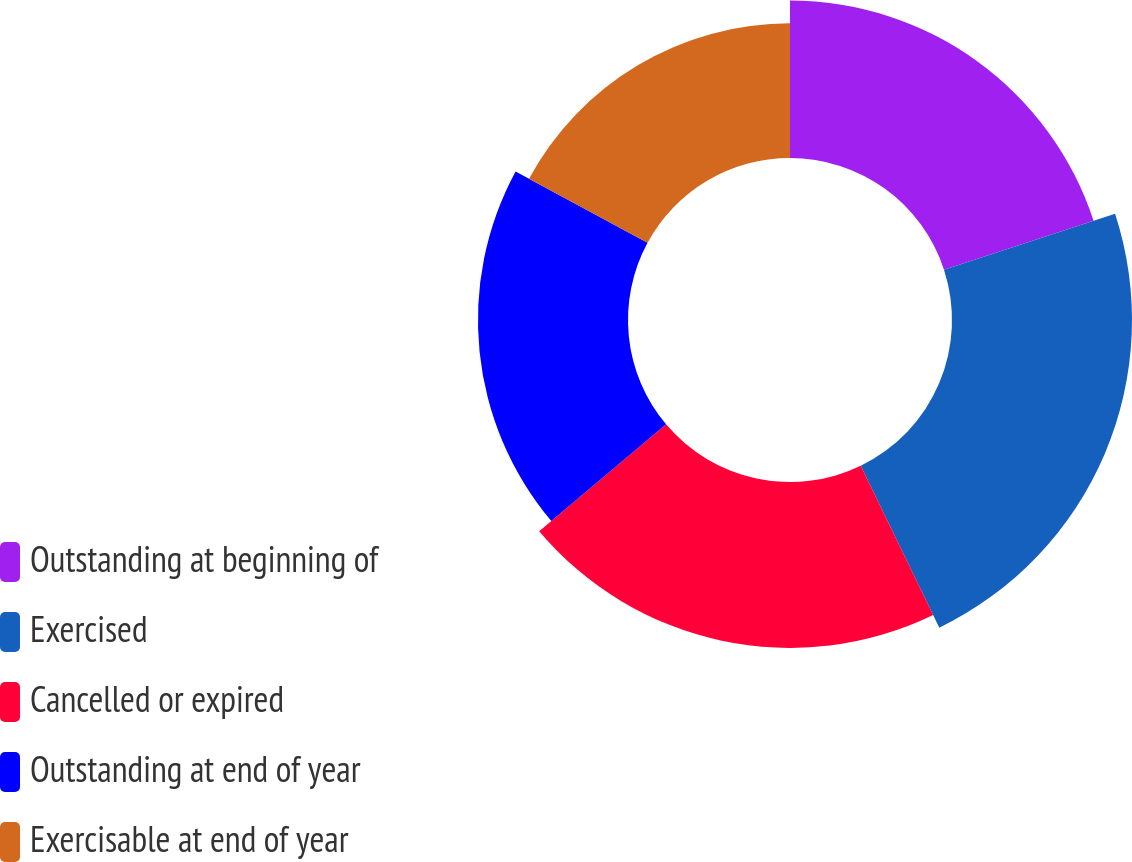Convert chart to OTSL. <chart><loc_0><loc_0><loc_500><loc_500><pie_chart><fcel>Outstanding at beginning of<fcel>Exercised<fcel>Cancelled or expired<fcel>Outstanding at end of year<fcel>Exercisable at end of year<nl><fcel>19.97%<fcel>22.84%<fcel>21.05%<fcel>19.04%<fcel>17.1%<nl></chart> 